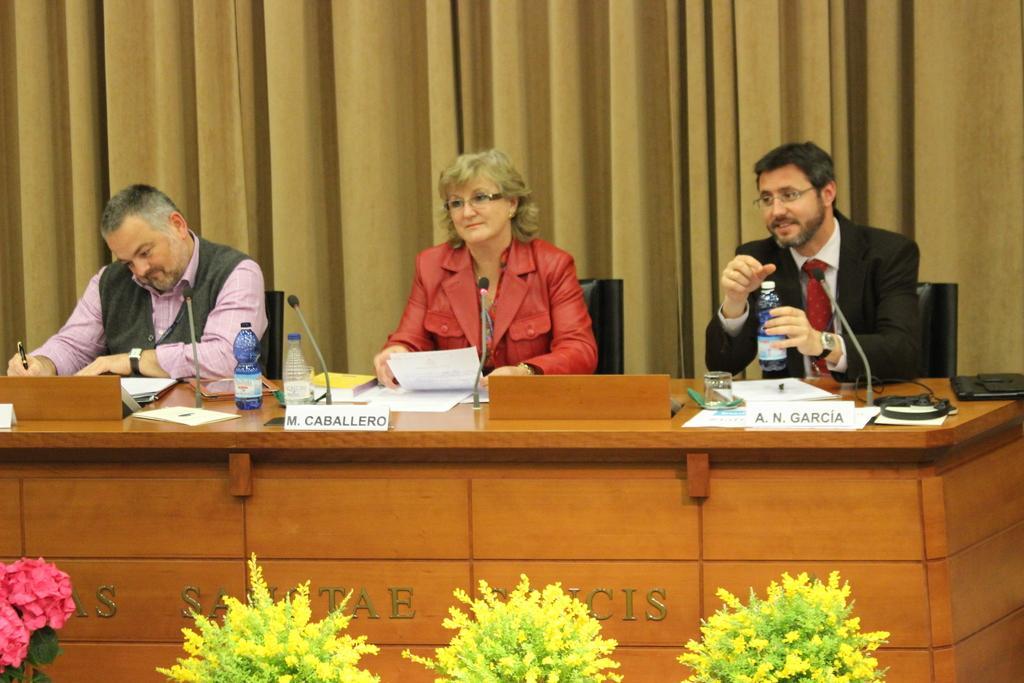Could you give a brief overview of what you see in this image? In this picture there are two men and a woman in the middle sitting behind the wooden table, smiling and giving a pose. In the front bottom side there is a some small plants pots. Behind there is a brown curtain. 